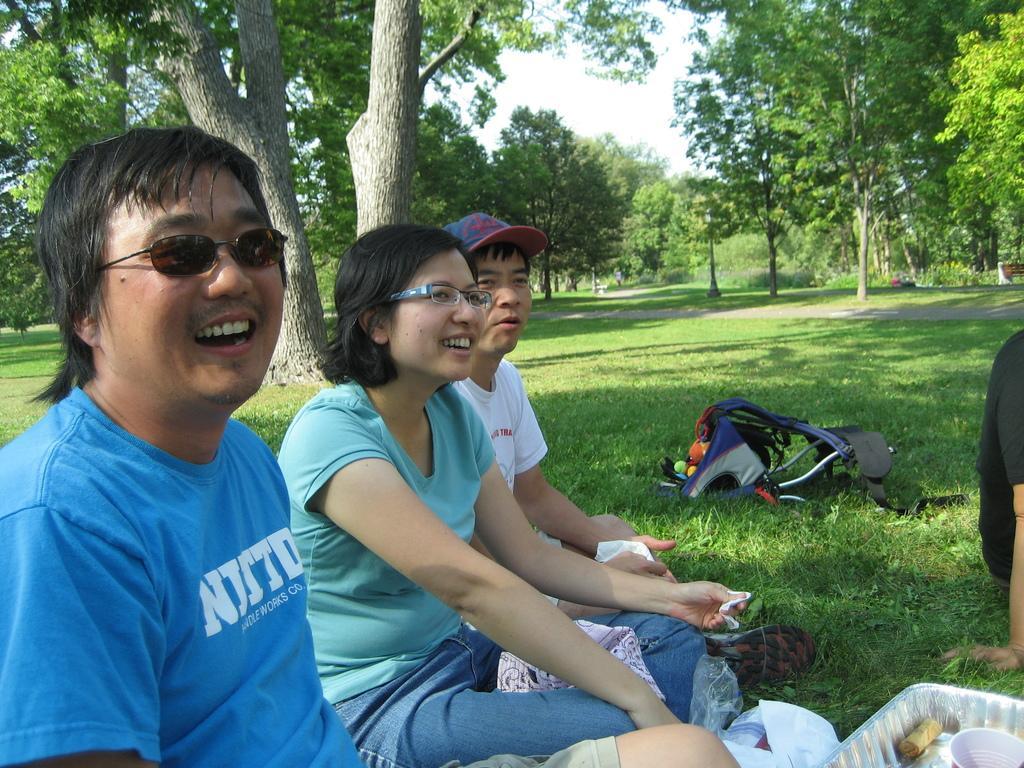Can you describe this image briefly? In this image in front there are four persons sitting on the surface of the grass. In front of them there are food items. Behind them there is a walker. At the center there is a road. In the background there are trees, benches and sky. 